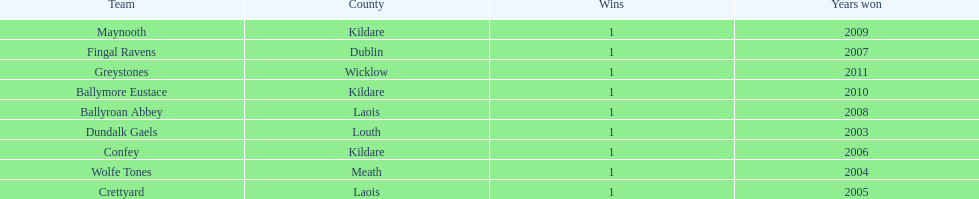What is the difference years won for crettyard and greystones 6. 